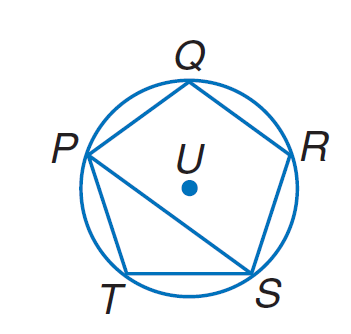Answer the mathemtical geometry problem and directly provide the correct option letter.
Question: Equilateral pentagon P Q R S T is inscribed in \odot U. Find m \angle P Q R.
Choices: A: 60 B: 72 C: 90 D: 108 D 